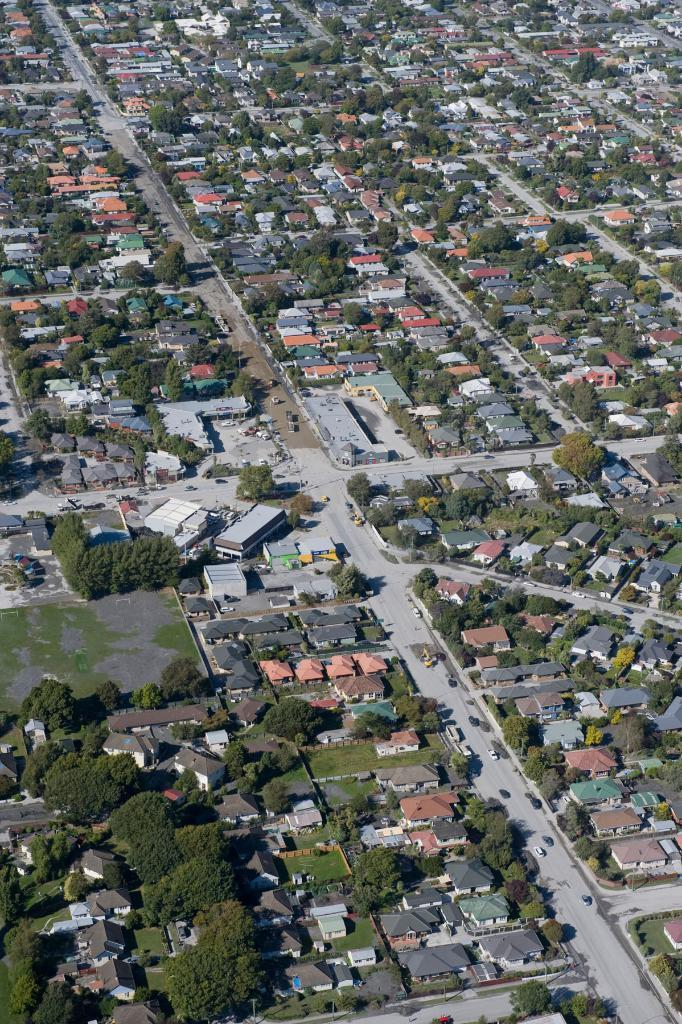What type of structures can be seen in the image? There are buildings in the image. What other natural elements are present in the image? There are trees in the image. What mode of transportation can be seen on the road in the image? There are vehicles on the road in the image. What type of riddle is being solved by the edge in the image? There is no edge or riddle present in the image. 